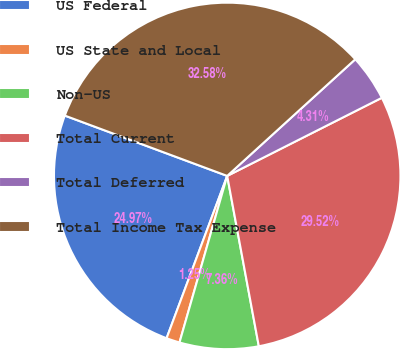Convert chart to OTSL. <chart><loc_0><loc_0><loc_500><loc_500><pie_chart><fcel>US Federal<fcel>US State and Local<fcel>Non-US<fcel>Total Current<fcel>Total Deferred<fcel>Total Income Tax Expense<nl><fcel>24.97%<fcel>1.25%<fcel>7.36%<fcel>29.52%<fcel>4.31%<fcel>32.58%<nl></chart> 